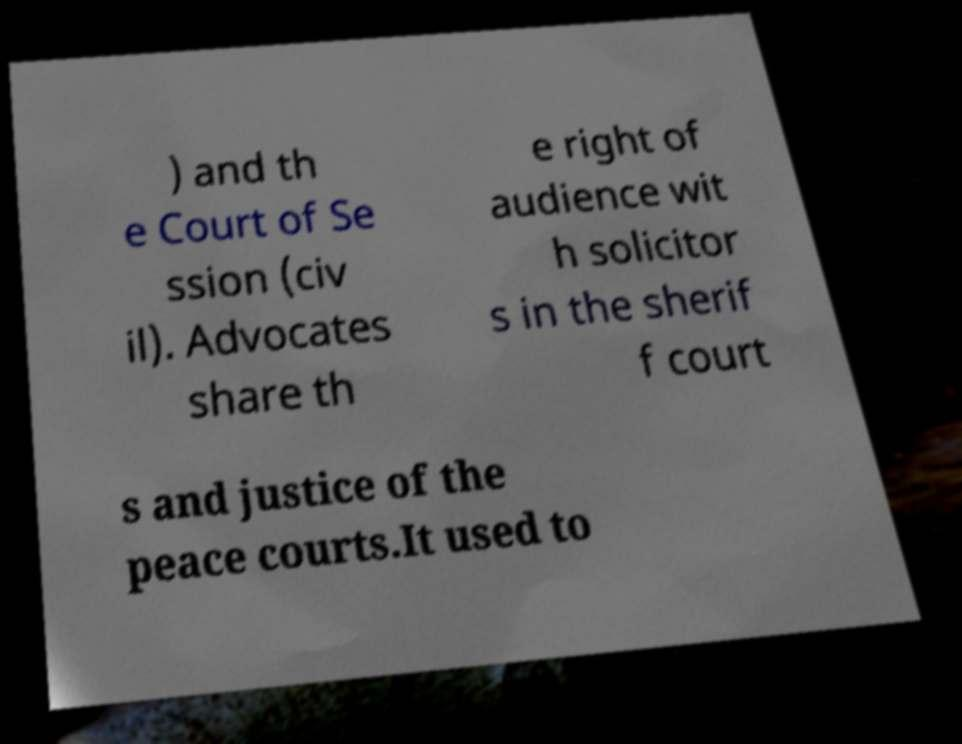Could you extract and type out the text from this image? ) and th e Court of Se ssion (civ il). Advocates share th e right of audience wit h solicitor s in the sherif f court s and justice of the peace courts.It used to 